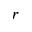<formula> <loc_0><loc_0><loc_500><loc_500>r</formula> 